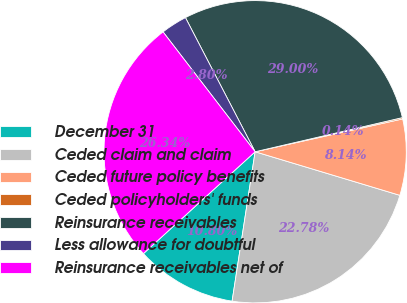Convert chart. <chart><loc_0><loc_0><loc_500><loc_500><pie_chart><fcel>December 31<fcel>Ceded claim and claim<fcel>Ceded future policy benefits<fcel>Ceded policyholders' funds<fcel>Reinsurance receivables<fcel>Less allowance for doubtful<fcel>Reinsurance receivables net of<nl><fcel>10.8%<fcel>22.78%<fcel>8.14%<fcel>0.14%<fcel>29.0%<fcel>2.8%<fcel>26.34%<nl></chart> 